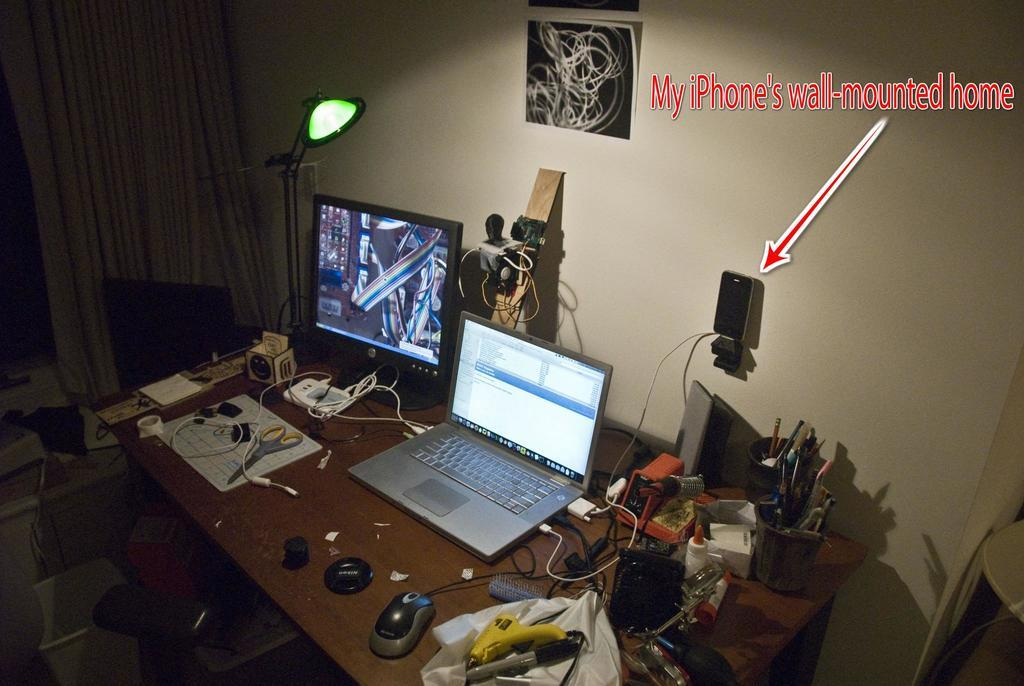<image>
Create a compact narrative representing the image presented. An iPhone mounted on the wall is displayed with an arrow pointing to it. 